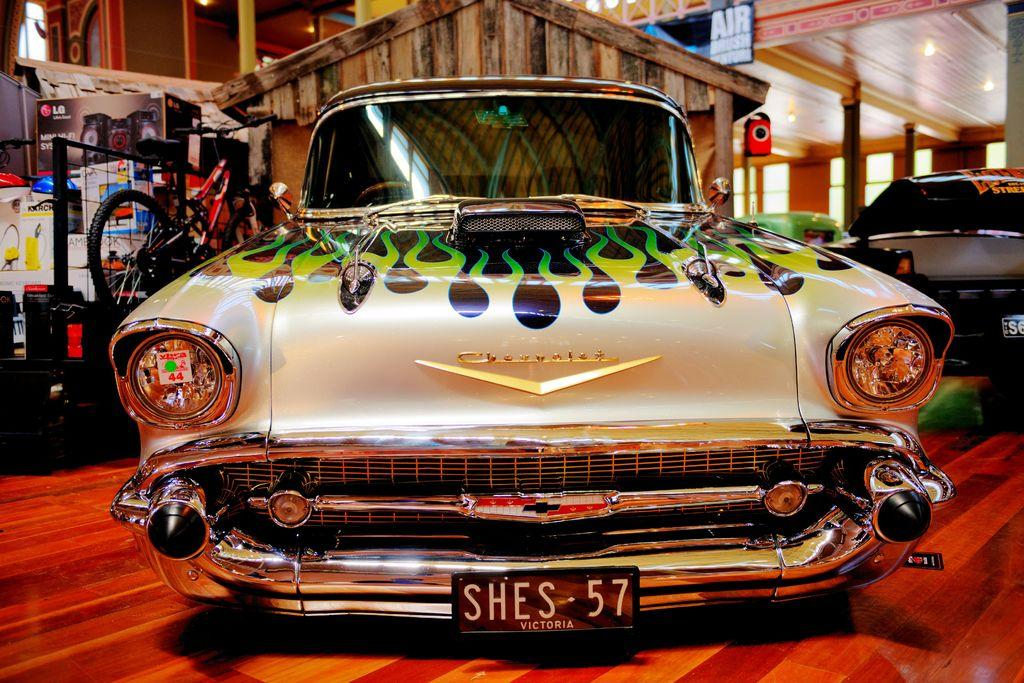What type of location is depicted in the image? The image is an inside view of a room. What vehicles can be seen in the image? There are cars visible in the image. What kind of signage is present in the image? There is a sign board in the image. What device is used for amplifying sound in the image? There is a speaker in the image. What type of lighting is present in the image? There are lights in the image. What part of the room's structure is visible in the image? The roof of the room is visible. What mode of transportation is present in the image besides cars? There is a bicycle in the image. What other objects can be seen in the image? There are other objects present in the image, but their specific details are not mentioned in the facts. What is visible on the floor in the image? The floor is visible in the image. Where is the cannon located in the image? There is no cannon present in the image. What type of cherry is used as a decoration on the sign board in the image? There is no cherry present on the sign board or in the image. What is inside the box that is visible in the image? There is no box present in the image. 